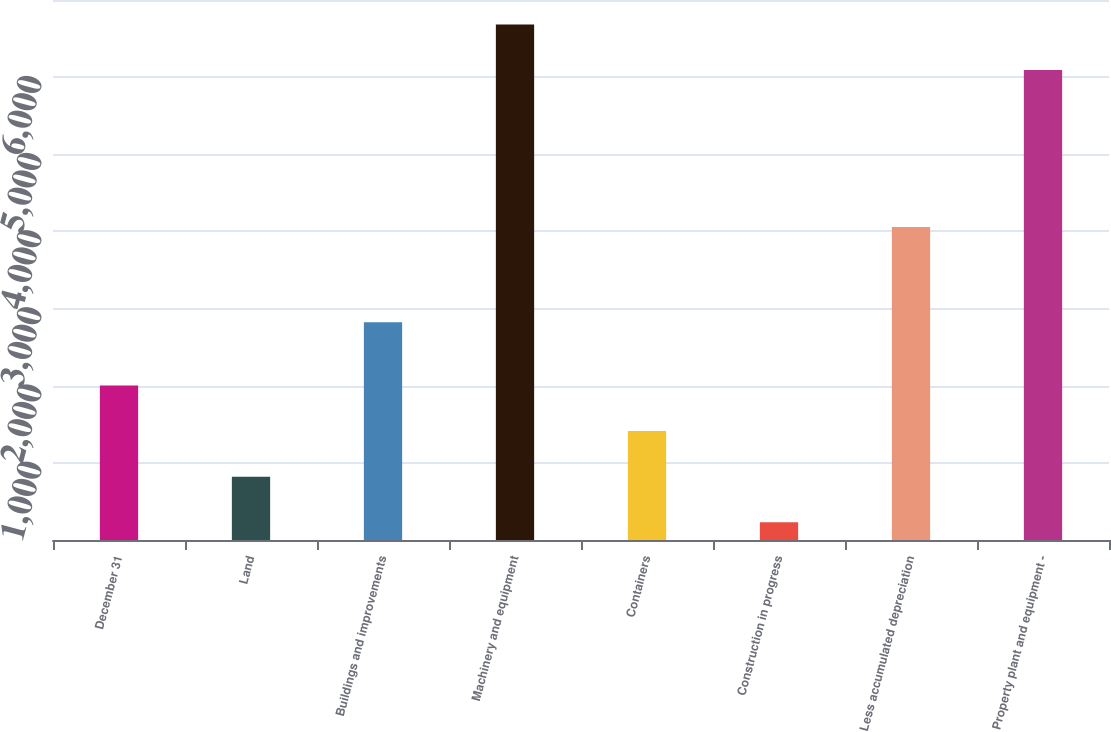<chart> <loc_0><loc_0><loc_500><loc_500><bar_chart><fcel>December 31<fcel>Land<fcel>Buildings and improvements<fcel>Machinery and equipment<fcel>Containers<fcel>Construction in progress<fcel>Less accumulated depreciation<fcel>Property plant and equipment -<nl><fcel>2004<fcel>820.8<fcel>2822<fcel>6681.8<fcel>1411.6<fcel>230<fcel>4058<fcel>6091<nl></chart> 